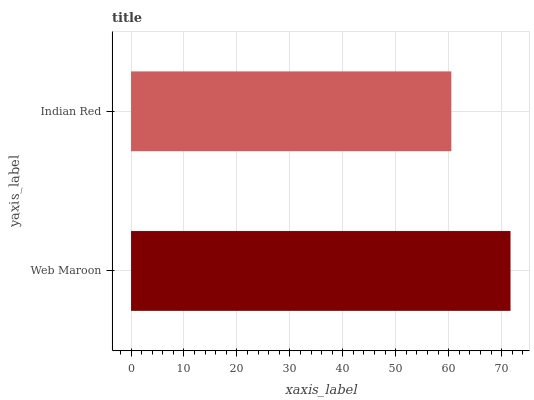Is Indian Red the minimum?
Answer yes or no. Yes. Is Web Maroon the maximum?
Answer yes or no. Yes. Is Indian Red the maximum?
Answer yes or no. No. Is Web Maroon greater than Indian Red?
Answer yes or no. Yes. Is Indian Red less than Web Maroon?
Answer yes or no. Yes. Is Indian Red greater than Web Maroon?
Answer yes or no. No. Is Web Maroon less than Indian Red?
Answer yes or no. No. Is Web Maroon the high median?
Answer yes or no. Yes. Is Indian Red the low median?
Answer yes or no. Yes. Is Indian Red the high median?
Answer yes or no. No. Is Web Maroon the low median?
Answer yes or no. No. 